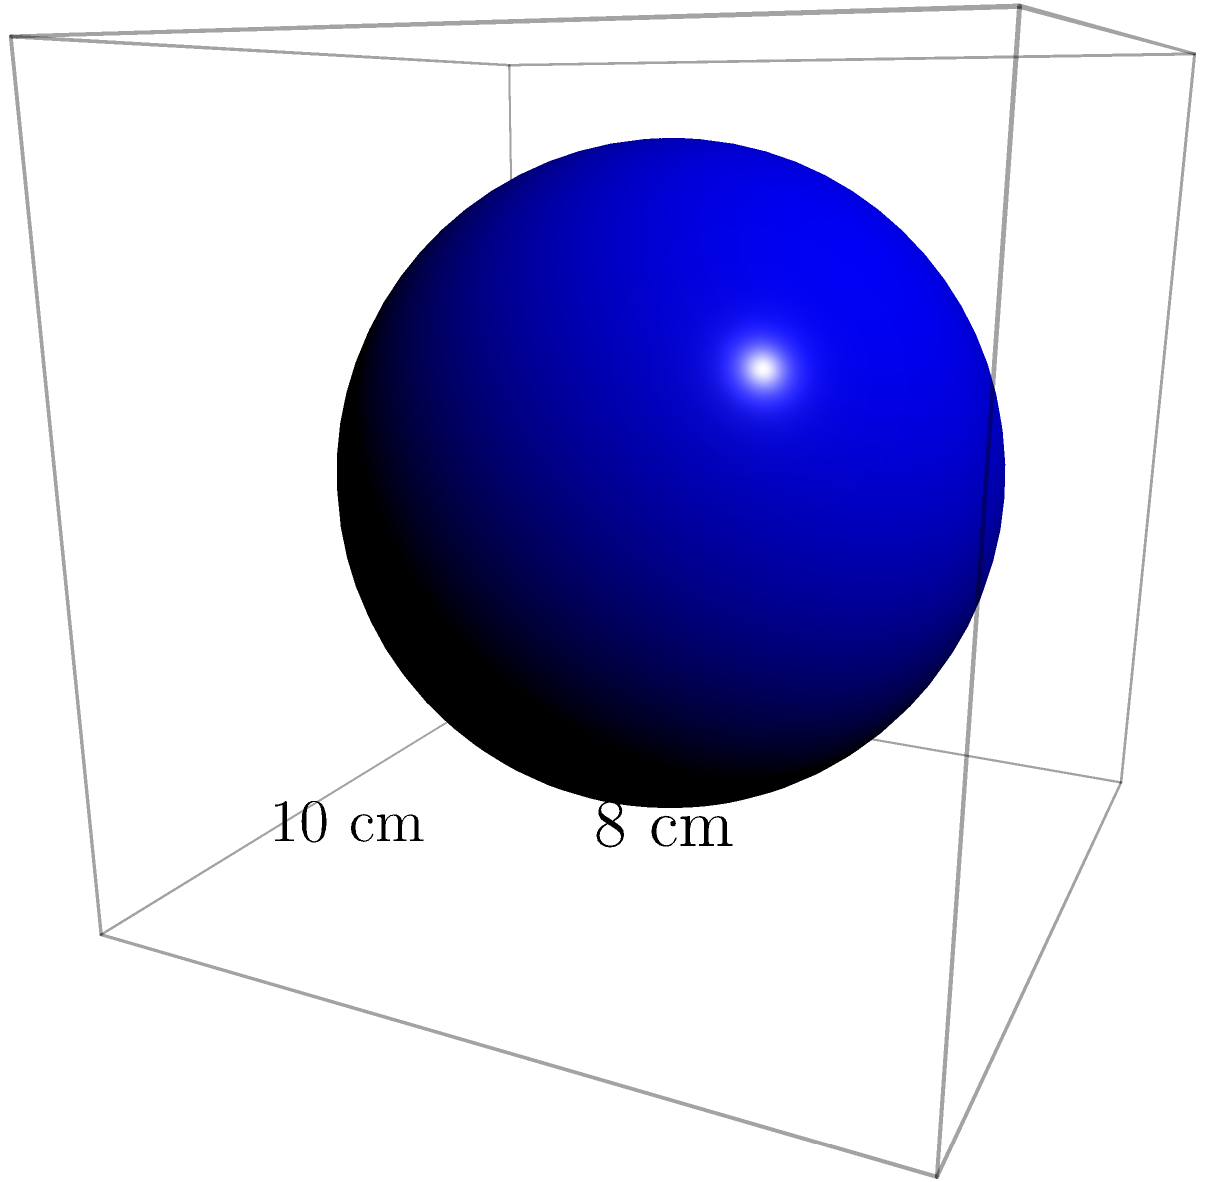A spherical artisanal cheese ball with a diameter of 8 cm is packaged in a cubic box with an inner edge length of 10 cm. What percentage of the box's volume is not occupied by the cheese ball? Round your answer to the nearest whole percent. To solve this problem, we need to follow these steps:

1. Calculate the volume of the cubic box:
   $$V_{box} = 10^3 = 1000 \text{ cm}^3$$

2. Calculate the volume of the spherical cheese ball:
   $$V_{sphere} = \frac{4}{3}\pi r^3 = \frac{4}{3}\pi (4^3) = \frac{256\pi}{3} \approx 268.08 \text{ cm}^3$$

3. Calculate the unoccupied volume:
   $$V_{unoccupied} = V_{box} - V_{sphere} = 1000 - 268.08 = 731.92 \text{ cm}^3$$

4. Calculate the percentage of unoccupied volume:
   $$\text{Percentage unoccupied} = \frac{V_{unoccupied}}{V_{box}} \times 100\% = \frac{731.92}{1000} \times 100\% \approx 73.19\%$$

5. Round to the nearest whole percent:
   73.19% rounds to 73%

Therefore, approximately 73% of the box's volume is not occupied by the cheese ball.
Answer: 73% 